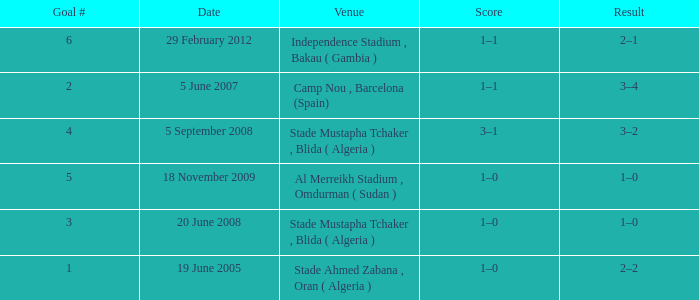What was the venue where goal #2 occured? Camp Nou , Barcelona (Spain). 